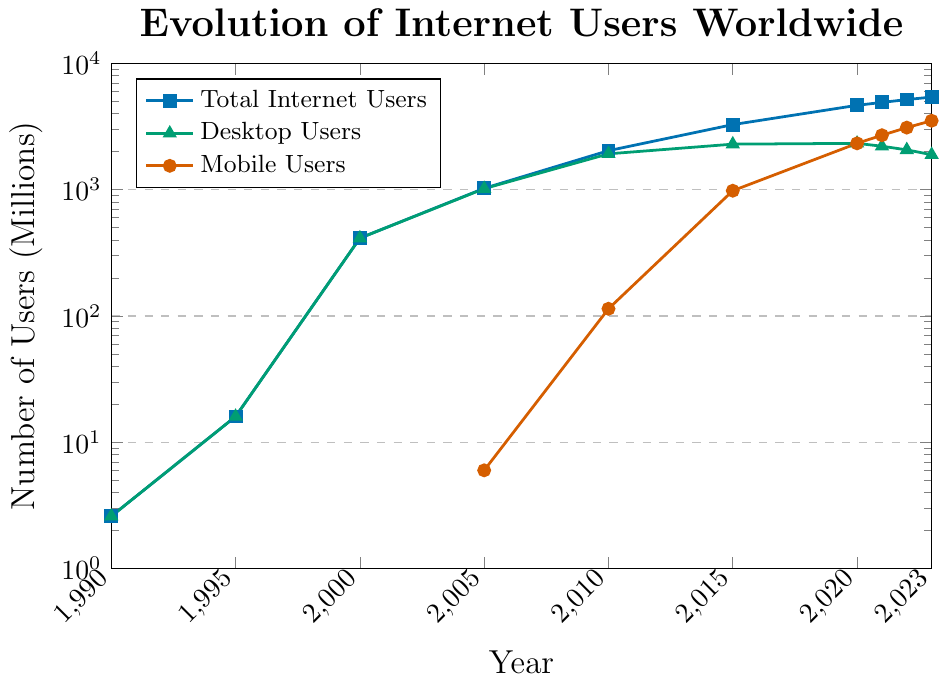What was the total number of internet users in 2000? Compare it to desktop users in 2000. The total number of internet users in 2000 was approximately 413 million. According to the figure, all of these users were desktop users as mobile users were not yet a contributing factor.
Answer: 413 million Which year saw the highest growth in mobile internet users? To determine the highest growth, we need to look at the steepest increase in the red line representing mobile users. Between 2015 and 2020, mobile users increased from 980 million to 2324 million, which is the highest increase of 1344 million users.
Answer: 2015 to 2020 By how much did the total number of internet users increase between 1995 and 2005? The total number of internet users was 16 million in 1995 and 1024 million in 2005. The increase is calculated as 1024 million - 16 million = 1008 million.
Answer: 1008 million How do the number of desktop users compare to the number of mobile users in 2023? In 2023, there are 1890 million desktop users and 3510 million mobile users. Mobile users are greater than desktop users by 3510 million - 1890 million = 1620 million users.
Answer: Mobile users are 1620 million more than desktop users Describe the change in desktop internet user numbers between 2010 and 2023. In 2010, there were 1920 million desktop users, and in 2023, there were 1890 million desktop users. This indicates a decrease of 1920 million - 1890 million = 30 million users over the period.
Answer: Decreased by 30 million What is the overall trend in the number of total internet users from 1990 to 2023? Observing the blue line, we can see that the total number of internet users has been increasing steadily over the years from 2.6 million in 1990 to 5400 million in 2023 without any decreases.
Answer: Increasing Which year marked the first significant rise in mobile internet users, and what was the value? The first significant rise in mobile internet users occurred in 2010 when the number of mobile users reached 114 million, noticeable on the red line which started at 0 until 2005.
Answer: 2010, 114 million If mobile internet users were 3096 million in 2022, what was the increase from 2021? In 2021, mobile internet users were 2695 million. The increase from 2021 to 2022 is calculated as 3096 million - 2695 million = 401 million.
Answer: 401 million Compare the rate of increase of total internet users from 1990 to 2000 and from 2000 to 2010. From 1990 (2.6 million) to 2000 (413 million), the rate of increase was 413 million - 2.6 million = 410.4 million. From 2000 (413 million) to 2010 (2034 million), the rate of increase was 2034 million - 413 million = 1621 million. The increase rate from 2000 to 2010 was higher by 1621 million - 410.4 million = 1210.6 million.
Answer: The rate of increase was higher from 2000 to 2010 by 1210.6 million 